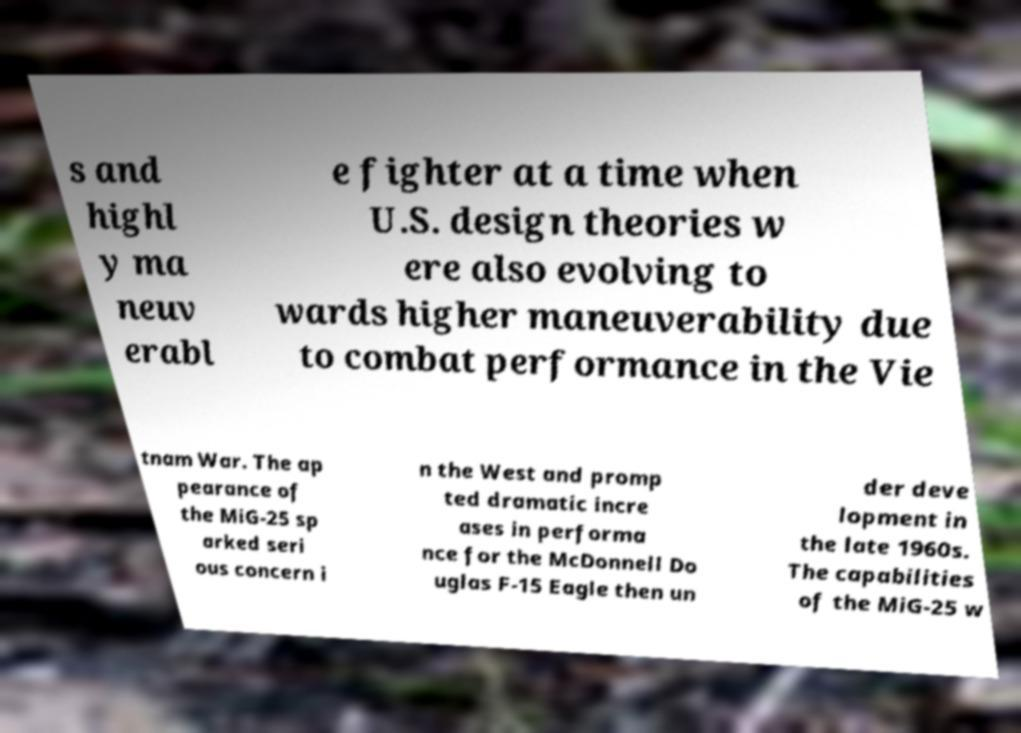Could you assist in decoding the text presented in this image and type it out clearly? s and highl y ma neuv erabl e fighter at a time when U.S. design theories w ere also evolving to wards higher maneuverability due to combat performance in the Vie tnam War. The ap pearance of the MiG-25 sp arked seri ous concern i n the West and promp ted dramatic incre ases in performa nce for the McDonnell Do uglas F-15 Eagle then un der deve lopment in the late 1960s. The capabilities of the MiG-25 w 